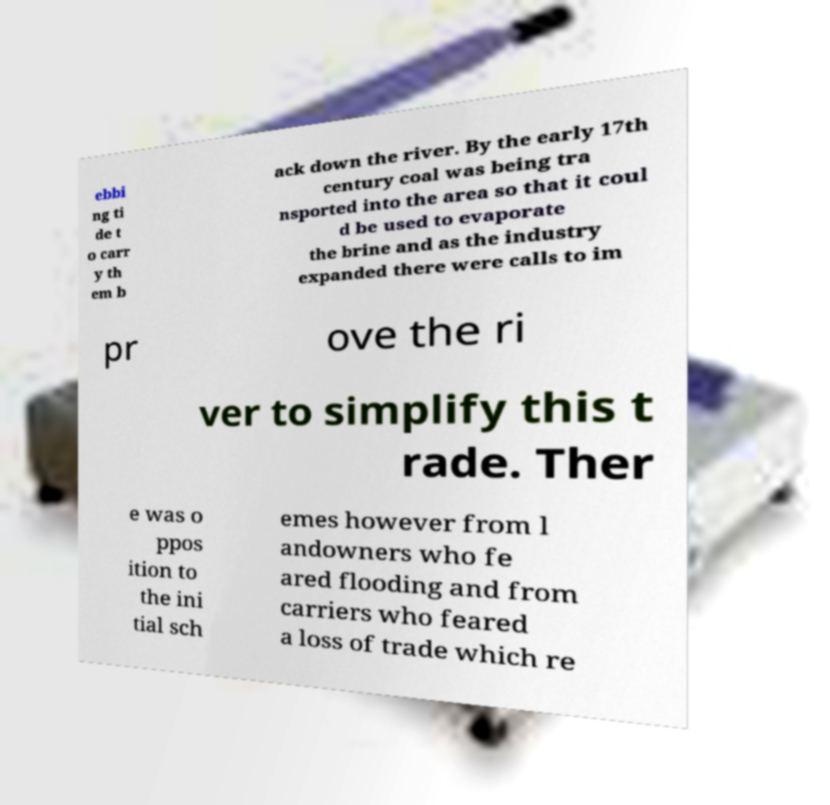Please read and relay the text visible in this image. What does it say? ebbi ng ti de t o carr y th em b ack down the river. By the early 17th century coal was being tra nsported into the area so that it coul d be used to evaporate the brine and as the industry expanded there were calls to im pr ove the ri ver to simplify this t rade. Ther e was o ppos ition to the ini tial sch emes however from l andowners who fe ared flooding and from carriers who feared a loss of trade which re 